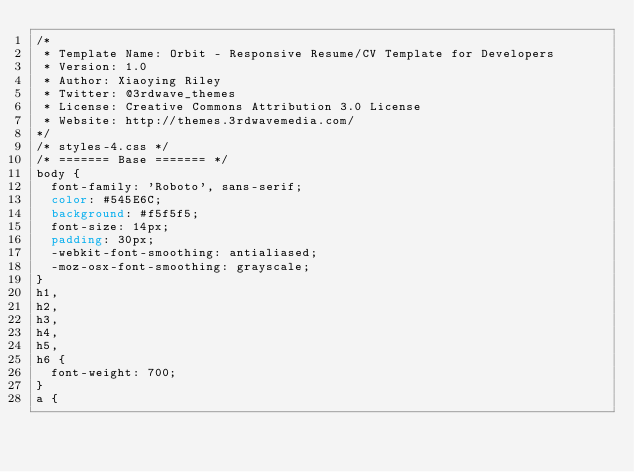<code> <loc_0><loc_0><loc_500><loc_500><_CSS_>/*   
 * Template Name: Orbit - Responsive Resume/CV Template for Developers
 * Version: 1.0
 * Author: Xiaoying Riley
 * Twitter: @3rdwave_themes
 * License: Creative Commons Attribution 3.0 License
 * Website: http://themes.3rdwavemedia.com/
*/
/* styles-4.css */
/* ======= Base ======= */
body {
  font-family: 'Roboto', sans-serif;
  color: #545E6C;
  background: #f5f5f5;
  font-size: 14px;
  padding: 30px;
  -webkit-font-smoothing: antialiased;
  -moz-osx-font-smoothing: grayscale;
}
h1,
h2,
h3,
h4,
h5,
h6 {
  font-weight: 700;
}
a {</code> 